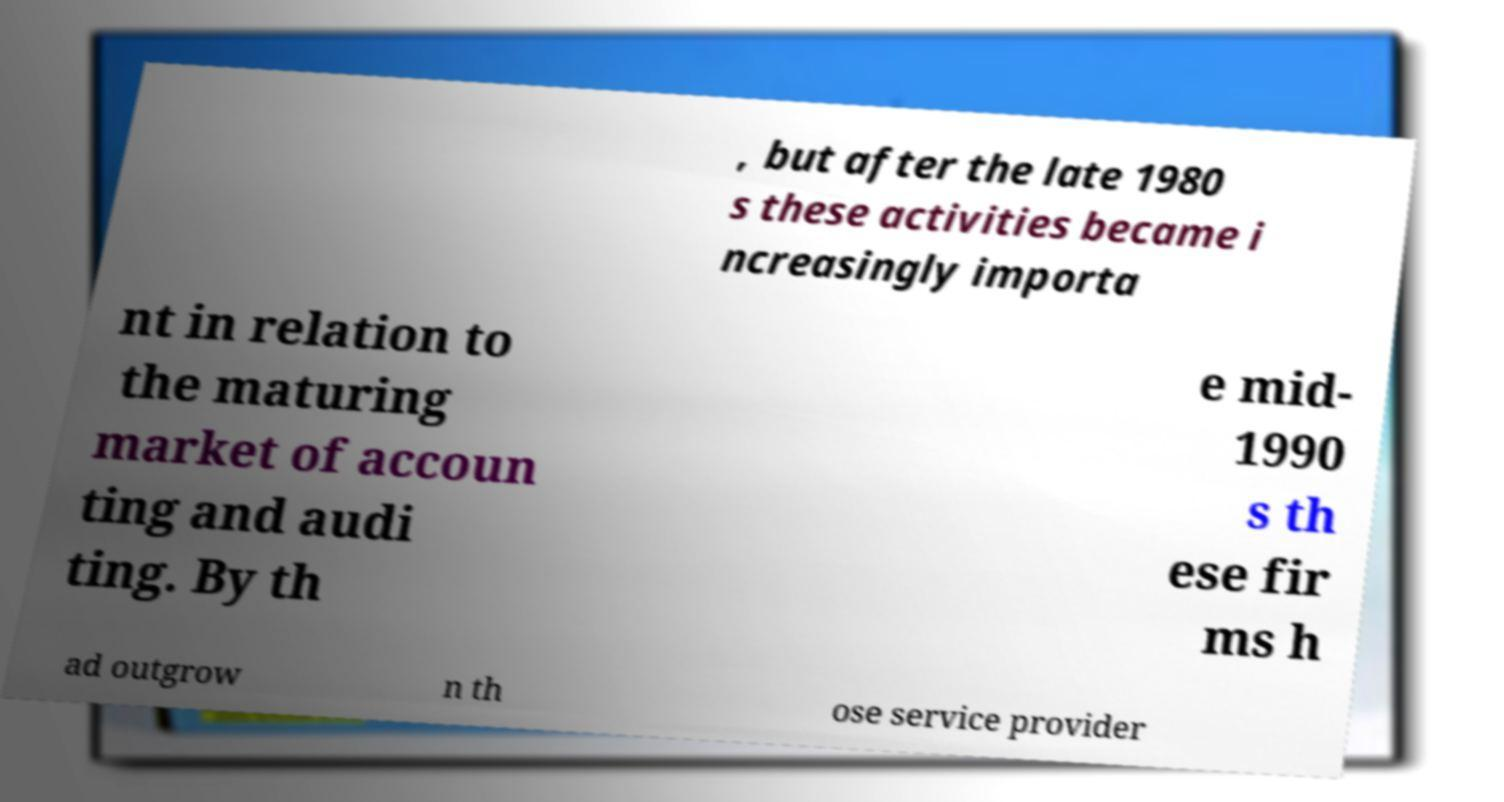I need the written content from this picture converted into text. Can you do that? , but after the late 1980 s these activities became i ncreasingly importa nt in relation to the maturing market of accoun ting and audi ting. By th e mid- 1990 s th ese fir ms h ad outgrow n th ose service provider 